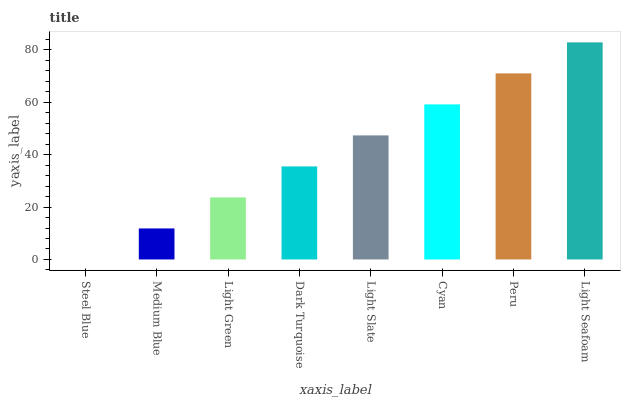Is Medium Blue the minimum?
Answer yes or no. No. Is Medium Blue the maximum?
Answer yes or no. No. Is Medium Blue greater than Steel Blue?
Answer yes or no. Yes. Is Steel Blue less than Medium Blue?
Answer yes or no. Yes. Is Steel Blue greater than Medium Blue?
Answer yes or no. No. Is Medium Blue less than Steel Blue?
Answer yes or no. No. Is Light Slate the high median?
Answer yes or no. Yes. Is Dark Turquoise the low median?
Answer yes or no. Yes. Is Peru the high median?
Answer yes or no. No. Is Light Slate the low median?
Answer yes or no. No. 